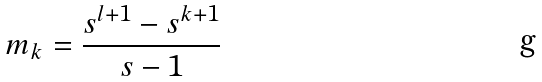<formula> <loc_0><loc_0><loc_500><loc_500>m _ { k } = \frac { s ^ { l + 1 } - s ^ { k + 1 } } { s - 1 }</formula> 